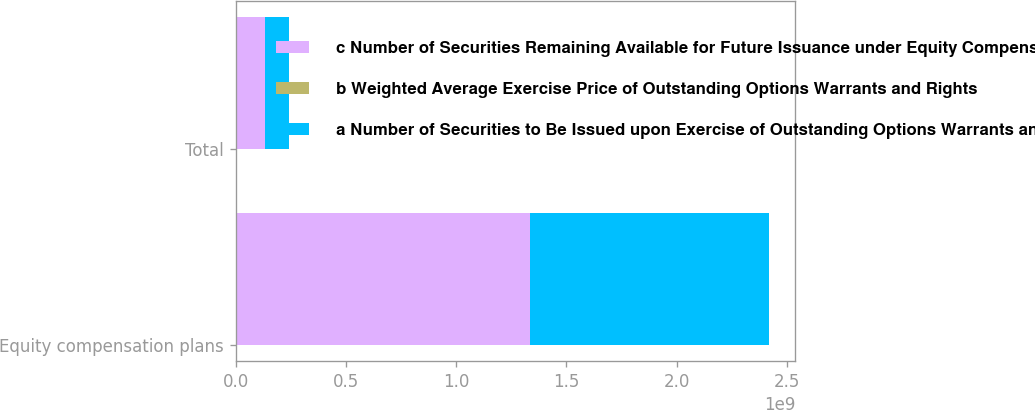<chart> <loc_0><loc_0><loc_500><loc_500><stacked_bar_chart><ecel><fcel>Equity compensation plans<fcel>Total<nl><fcel>c Number of Securities Remaining Available for Future Issuance under Equity Compensation Plans Excluding Securities Reflected in Columna<fcel>1.33608e+09<fcel>1.34377e+08<nl><fcel>b Weighted Average Exercise Price of Outstanding Options Warrants and Rights<fcel>31.01<fcel>30.83<nl><fcel>a Number of Securities to Be Issued upon Exercise of Outstanding Options Warrants and Rights<fcel>1.08067e+09<fcel>1.08067e+08<nl></chart> 